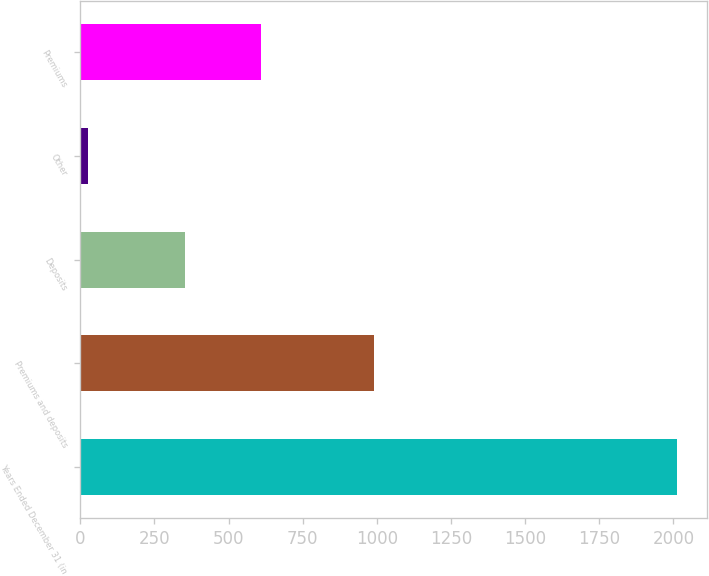Convert chart to OTSL. <chart><loc_0><loc_0><loc_500><loc_500><bar_chart><fcel>Years Ended December 31 (in<fcel>Premiums and deposits<fcel>Deposits<fcel>Other<fcel>Premiums<nl><fcel>2013<fcel>991<fcel>354<fcel>27<fcel>610<nl></chart> 